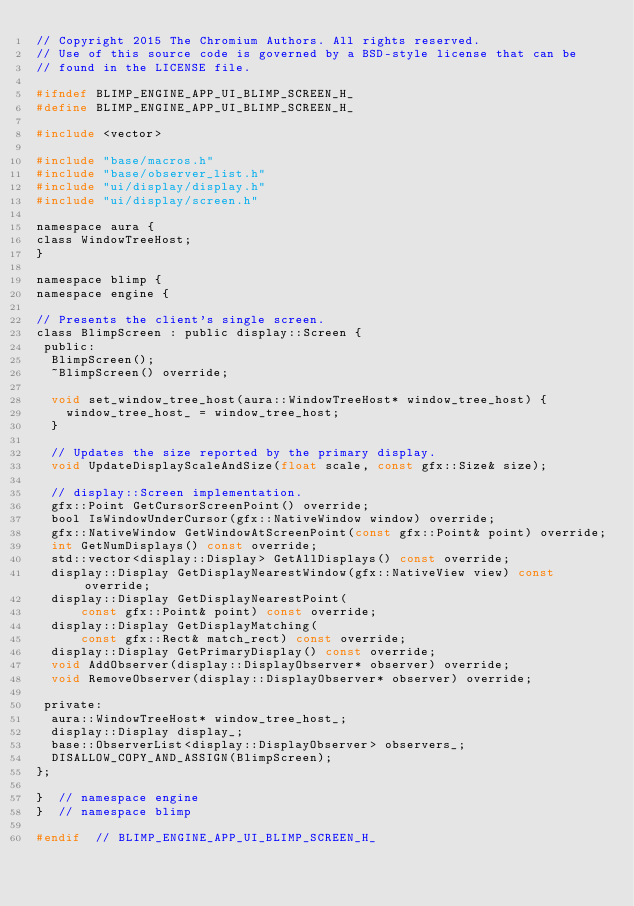Convert code to text. <code><loc_0><loc_0><loc_500><loc_500><_C_>// Copyright 2015 The Chromium Authors. All rights reserved.
// Use of this source code is governed by a BSD-style license that can be
// found in the LICENSE file.

#ifndef BLIMP_ENGINE_APP_UI_BLIMP_SCREEN_H_
#define BLIMP_ENGINE_APP_UI_BLIMP_SCREEN_H_

#include <vector>

#include "base/macros.h"
#include "base/observer_list.h"
#include "ui/display/display.h"
#include "ui/display/screen.h"

namespace aura {
class WindowTreeHost;
}

namespace blimp {
namespace engine {

// Presents the client's single screen.
class BlimpScreen : public display::Screen {
 public:
  BlimpScreen();
  ~BlimpScreen() override;

  void set_window_tree_host(aura::WindowTreeHost* window_tree_host) {
    window_tree_host_ = window_tree_host;
  }

  // Updates the size reported by the primary display.
  void UpdateDisplayScaleAndSize(float scale, const gfx::Size& size);

  // display::Screen implementation.
  gfx::Point GetCursorScreenPoint() override;
  bool IsWindowUnderCursor(gfx::NativeWindow window) override;
  gfx::NativeWindow GetWindowAtScreenPoint(const gfx::Point& point) override;
  int GetNumDisplays() const override;
  std::vector<display::Display> GetAllDisplays() const override;
  display::Display GetDisplayNearestWindow(gfx::NativeView view) const override;
  display::Display GetDisplayNearestPoint(
      const gfx::Point& point) const override;
  display::Display GetDisplayMatching(
      const gfx::Rect& match_rect) const override;
  display::Display GetPrimaryDisplay() const override;
  void AddObserver(display::DisplayObserver* observer) override;
  void RemoveObserver(display::DisplayObserver* observer) override;

 private:
  aura::WindowTreeHost* window_tree_host_;
  display::Display display_;
  base::ObserverList<display::DisplayObserver> observers_;
  DISALLOW_COPY_AND_ASSIGN(BlimpScreen);
};

}  // namespace engine
}  // namespace blimp

#endif  // BLIMP_ENGINE_APP_UI_BLIMP_SCREEN_H_
</code> 